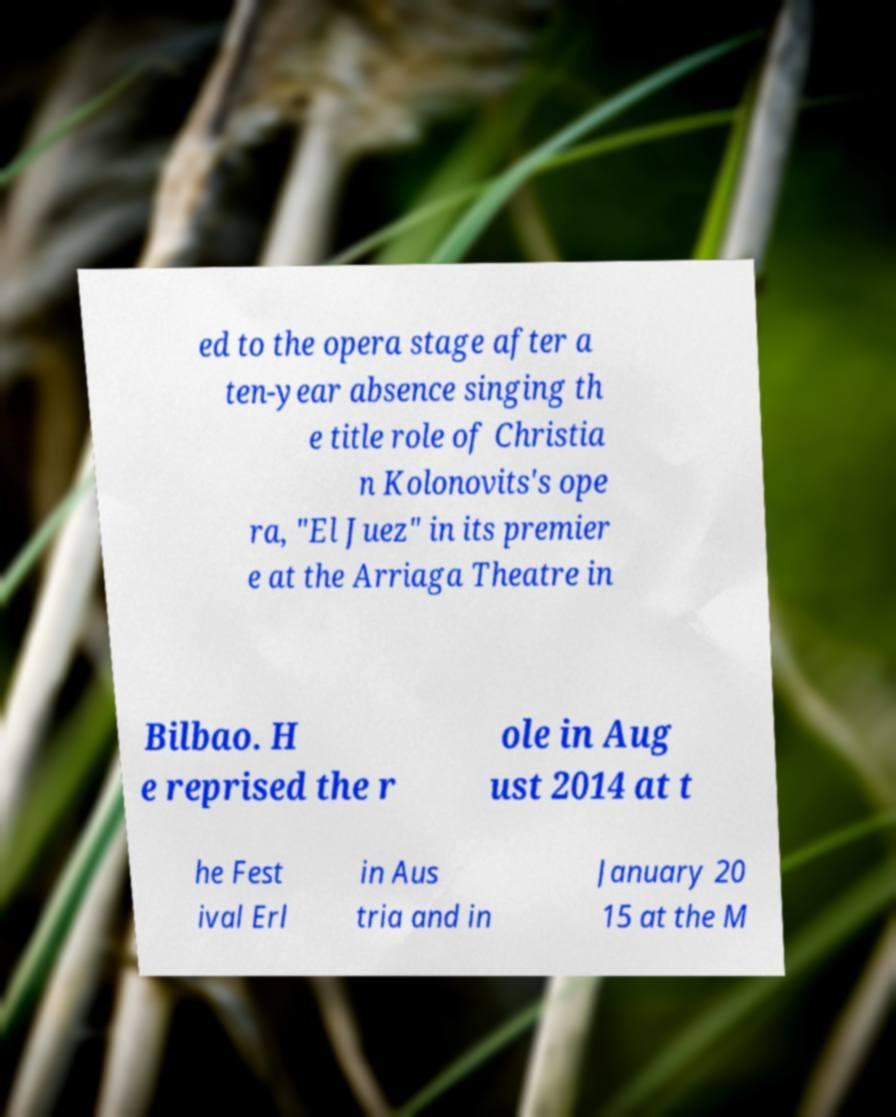Could you extract and type out the text from this image? ed to the opera stage after a ten-year absence singing th e title role of Christia n Kolonovits's ope ra, "El Juez" in its premier e at the Arriaga Theatre in Bilbao. H e reprised the r ole in Aug ust 2014 at t he Fest ival Erl in Aus tria and in January 20 15 at the M 